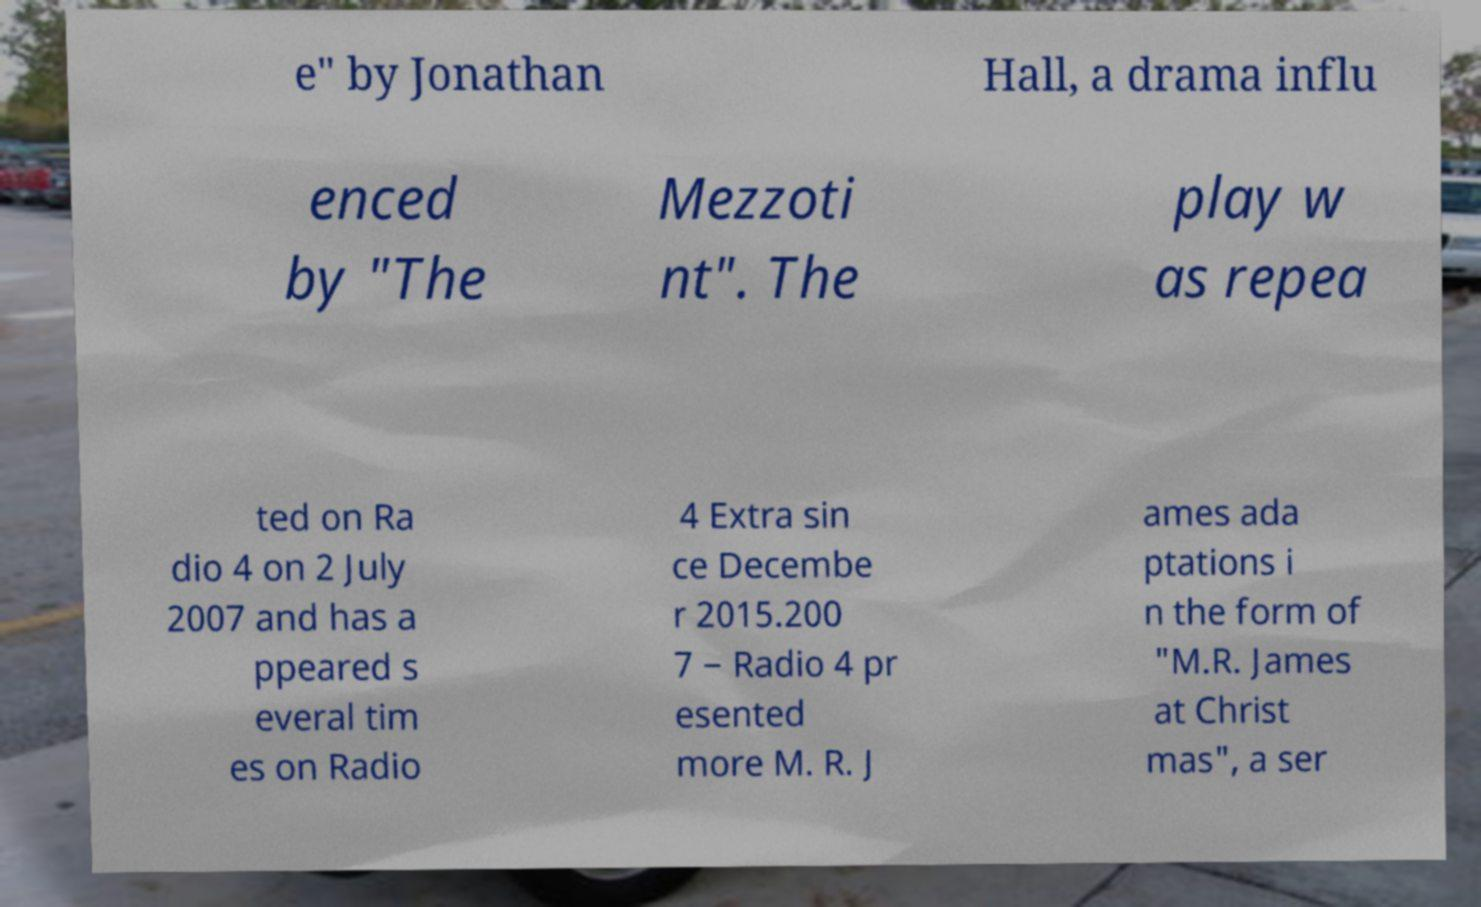For documentation purposes, I need the text within this image transcribed. Could you provide that? e" by Jonathan Hall, a drama influ enced by "The Mezzoti nt". The play w as repea ted on Ra dio 4 on 2 July 2007 and has a ppeared s everal tim es on Radio 4 Extra sin ce Decembe r 2015.200 7 − Radio 4 pr esented more M. R. J ames ada ptations i n the form of "M.R. James at Christ mas", a ser 